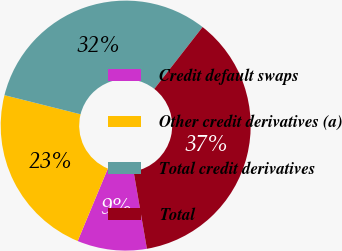<chart> <loc_0><loc_0><loc_500><loc_500><pie_chart><fcel>Credit default swaps<fcel>Other credit derivatives (a)<fcel>Total credit derivatives<fcel>Total<nl><fcel>8.99%<fcel>22.64%<fcel>31.63%<fcel>36.74%<nl></chart> 